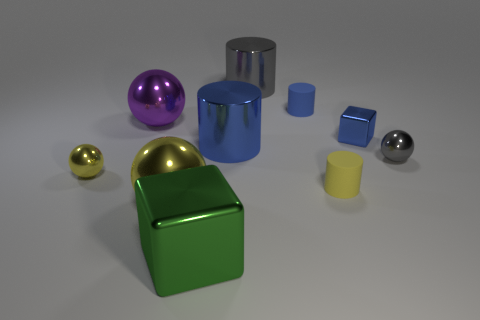What is the arrangement of objects in this image? The objects are arranged seemingly at random on a flat surface. This eclectic configuration with varying distances between objects suggests no particular pattern, emphasizing their individual shapes and colors. 